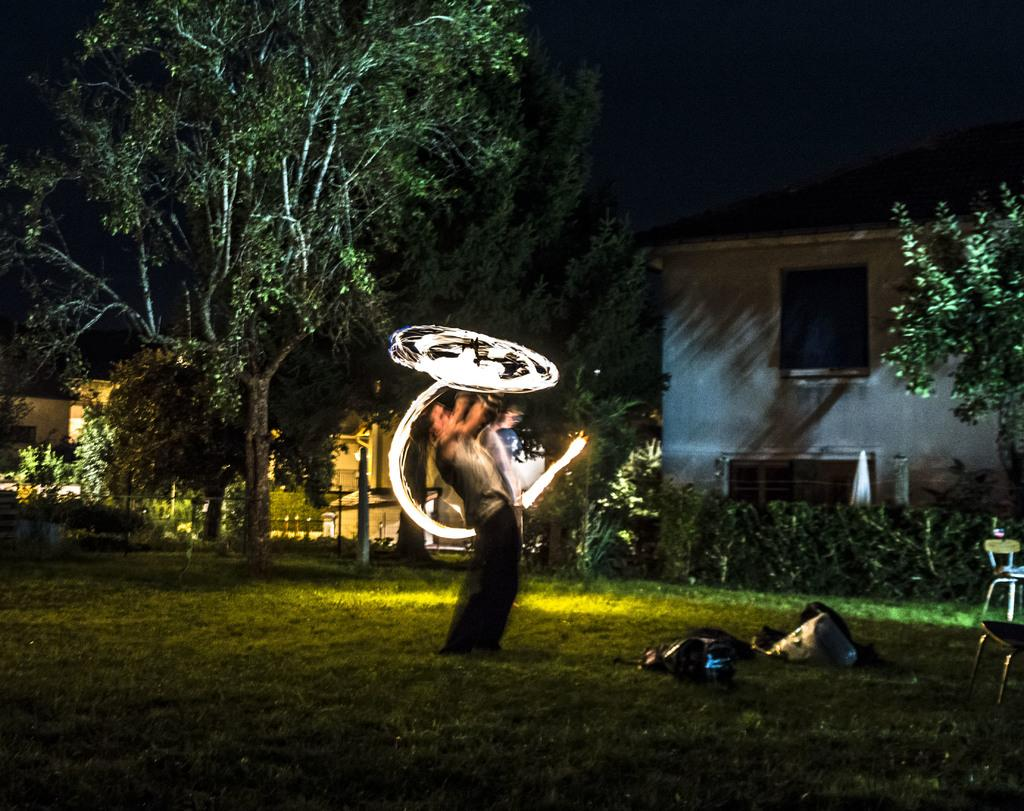What type of vegetation can be seen in the image? There is grass and plants in the image. What is the man in the image doing? The man is standing in the image. What other natural elements are present in the image? There are trees in the image. What type of structures can be seen in the image? There are houses in the image. How would you describe the lighting in the image? The image is slightly dark. What type of books can be found in the library depicted in the image? There is no library present in the image, so it is not possible to determine what type of books might be found there. 